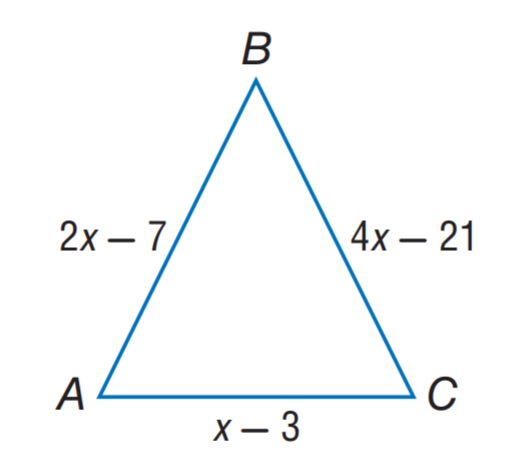Answer the mathemtical geometry problem and directly provide the correct option letter.
Question: Find A C if \triangle A B C is an isosceles triangle with A B \cong B C.
Choices: A: 3 B: 4 C: 7 D: 11 B 